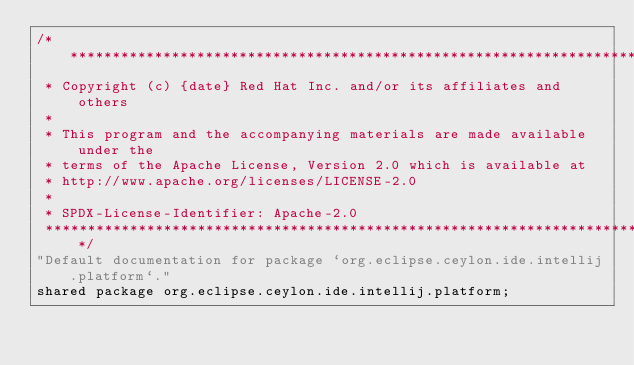Convert code to text. <code><loc_0><loc_0><loc_500><loc_500><_Ceylon_>/********************************************************************************
 * Copyright (c) {date} Red Hat Inc. and/or its affiliates and others
 *
 * This program and the accompanying materials are made available under the 
 * terms of the Apache License, Version 2.0 which is available at
 * http://www.apache.org/licenses/LICENSE-2.0
 *
 * SPDX-License-Identifier: Apache-2.0 
 ********************************************************************************/
"Default documentation for package `org.eclipse.ceylon.ide.intellij.platform`."
shared package org.eclipse.ceylon.ide.intellij.platform;
</code> 